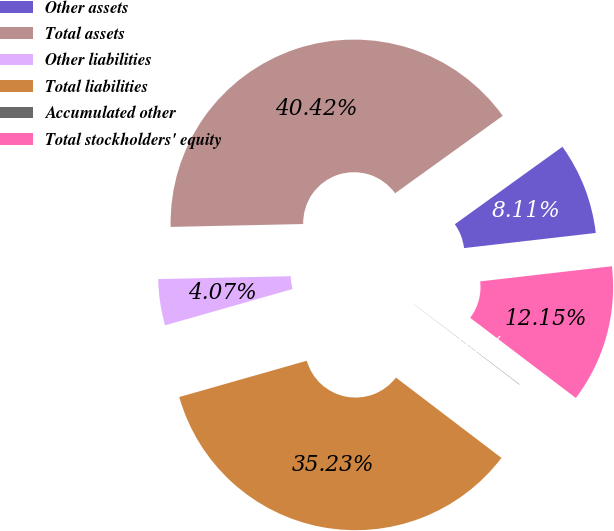Convert chart. <chart><loc_0><loc_0><loc_500><loc_500><pie_chart><fcel>Other assets<fcel>Total assets<fcel>Other liabilities<fcel>Total liabilities<fcel>Accumulated other<fcel>Total stockholders' equity<nl><fcel>8.11%<fcel>40.42%<fcel>4.07%<fcel>35.23%<fcel>0.03%<fcel>12.15%<nl></chart> 